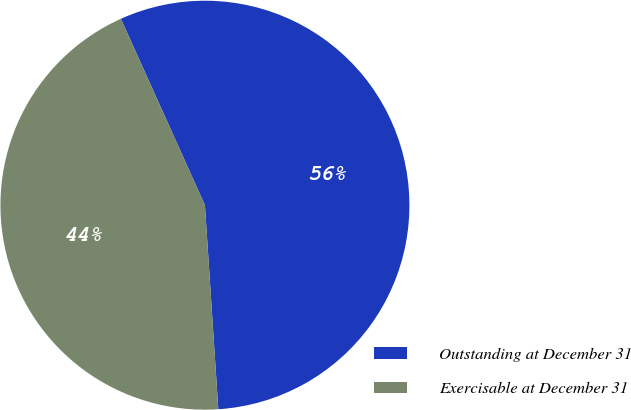<chart> <loc_0><loc_0><loc_500><loc_500><pie_chart><fcel>Outstanding at December 31<fcel>Exercisable at December 31<nl><fcel>55.7%<fcel>44.3%<nl></chart> 